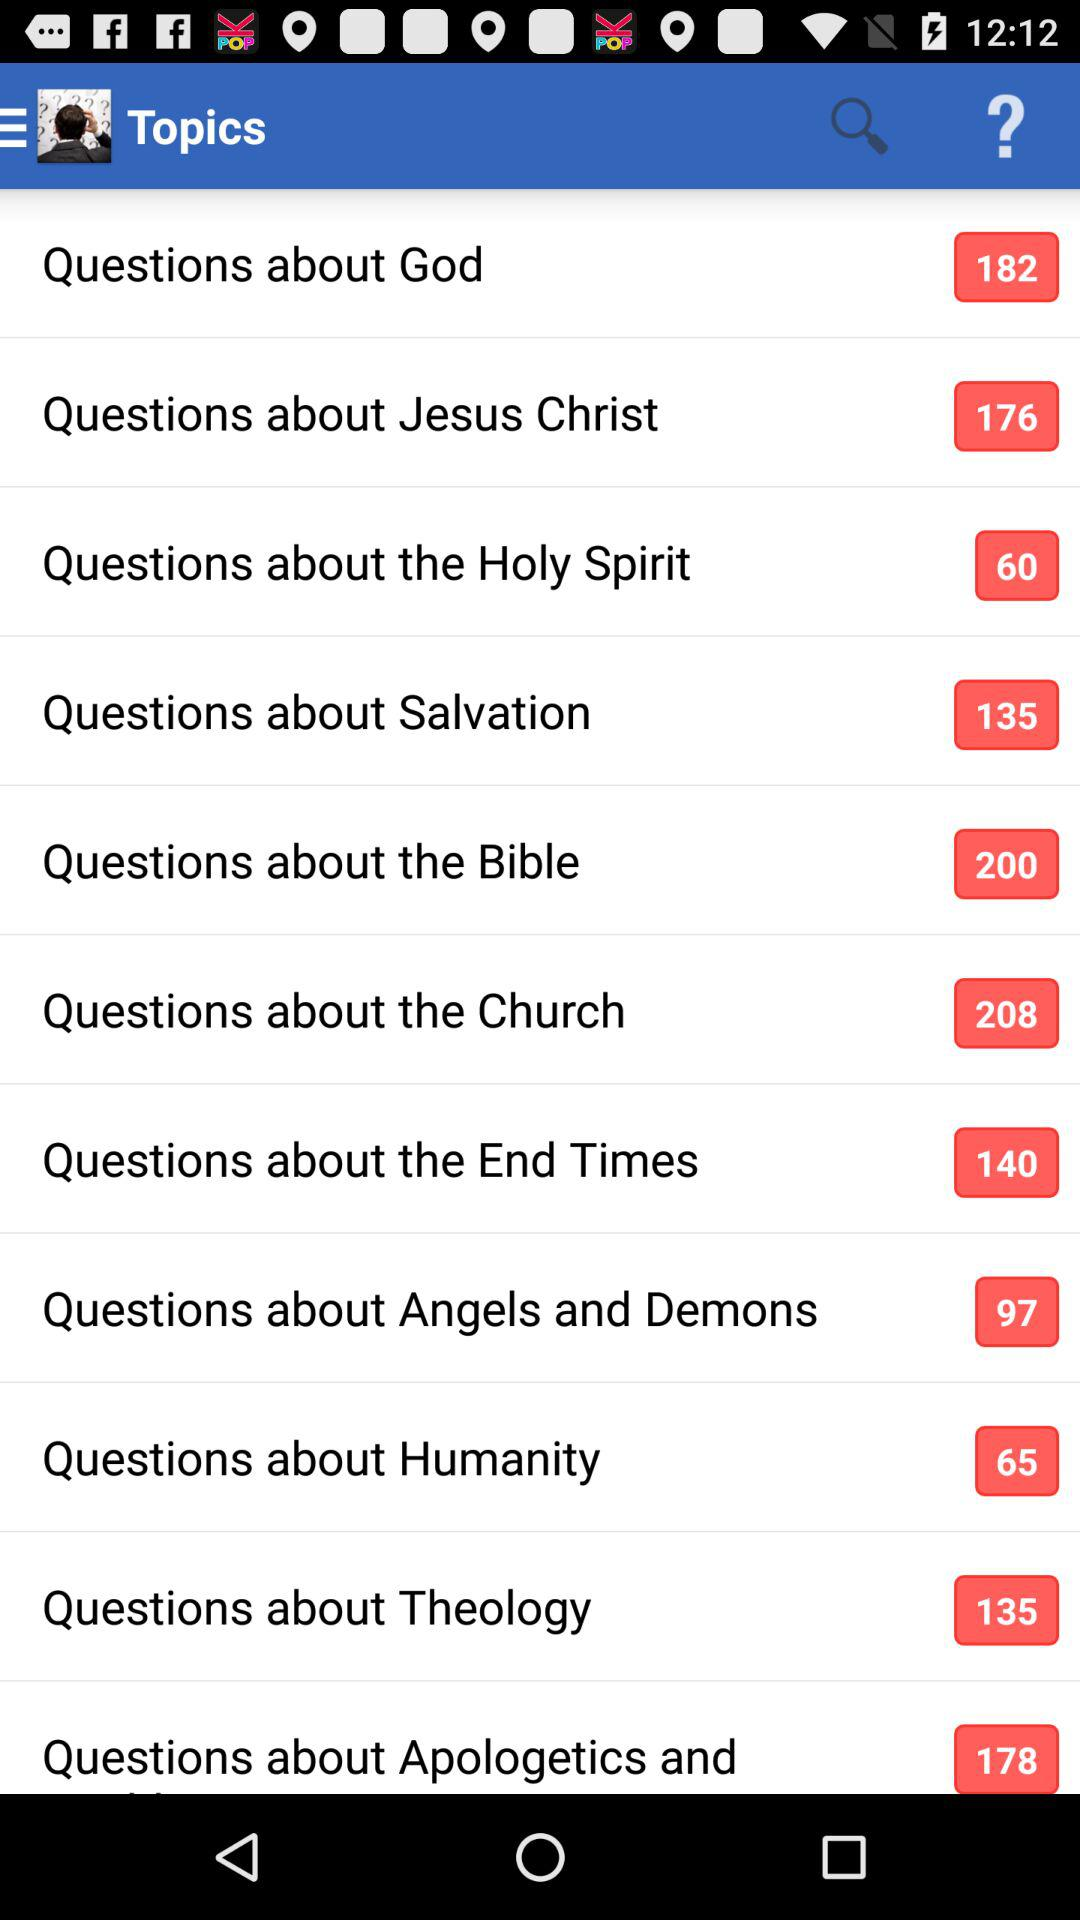How many questions are there about God? There are 182 questions about God. 